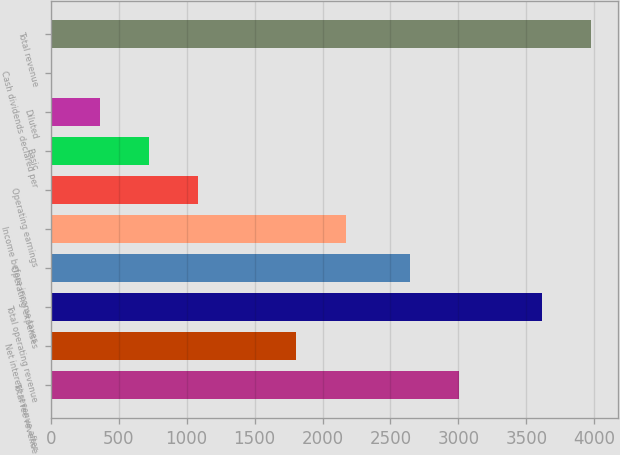Convert chart. <chart><loc_0><loc_0><loc_500><loc_500><bar_chart><fcel>Total fee revenue<fcel>Net interest revenue after<fcel>Total operating revenue<fcel>Operating expenses<fcel>Income before income taxes<fcel>Operating earnings<fcel>Basic<fcel>Diluted<fcel>Cash dividends declared per<fcel>Total revenue<nl><fcel>3005.47<fcel>1807.69<fcel>3615<fcel>2644<fcel>2169.16<fcel>1084.75<fcel>723.28<fcel>361.81<fcel>0.34<fcel>3976.47<nl></chart> 